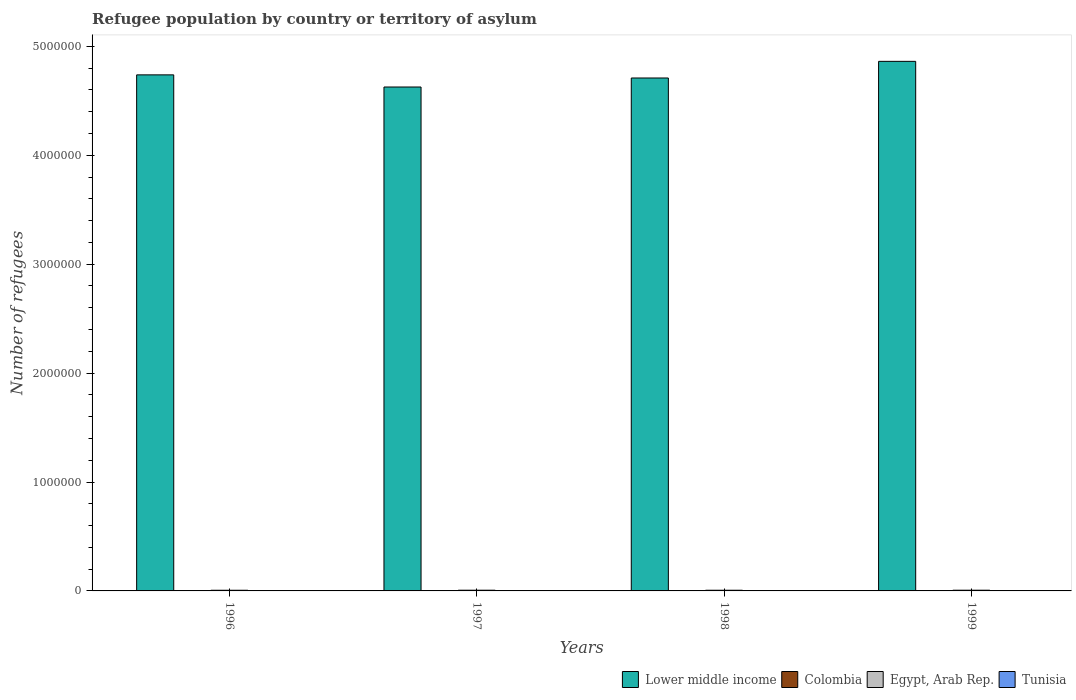How many groups of bars are there?
Your answer should be compact. 4. How many bars are there on the 4th tick from the right?
Your answer should be compact. 4. What is the label of the 1st group of bars from the left?
Give a very brief answer. 1996. In how many cases, is the number of bars for a given year not equal to the number of legend labels?
Give a very brief answer. 0. What is the number of refugees in Colombia in 1999?
Your answer should be very brief. 230. Across all years, what is the maximum number of refugees in Lower middle income?
Your answer should be compact. 4.86e+06. Across all years, what is the minimum number of refugees in Lower middle income?
Keep it short and to the point. 4.63e+06. What is the total number of refugees in Lower middle income in the graph?
Offer a very short reply. 1.89e+07. What is the difference between the number of refugees in Tunisia in 1997 and that in 1999?
Your answer should be very brief. 52. What is the difference between the number of refugees in Egypt, Arab Rep. in 1997 and the number of refugees in Lower middle income in 1996?
Ensure brevity in your answer.  -4.73e+06. What is the average number of refugees in Egypt, Arab Rep. per year?
Ensure brevity in your answer.  6339.25. In the year 1997, what is the difference between the number of refugees in Colombia and number of refugees in Tunisia?
Ensure brevity in your answer.  -283. What is the ratio of the number of refugees in Egypt, Arab Rep. in 1996 to that in 1999?
Ensure brevity in your answer.  0.92. Is the number of refugees in Tunisia in 1998 less than that in 1999?
Provide a short and direct response. No. What is the difference between the highest and the lowest number of refugees in Egypt, Arab Rep.?
Make the answer very short. 518. Is the sum of the number of refugees in Lower middle income in 1998 and 1999 greater than the maximum number of refugees in Egypt, Arab Rep. across all years?
Keep it short and to the point. Yes. What does the 1st bar from the left in 1999 represents?
Your answer should be compact. Lower middle income. What does the 1st bar from the right in 1997 represents?
Your answer should be very brief. Tunisia. Is it the case that in every year, the sum of the number of refugees in Egypt, Arab Rep. and number of refugees in Tunisia is greater than the number of refugees in Lower middle income?
Your answer should be very brief. No. How many years are there in the graph?
Make the answer very short. 4. What is the difference between two consecutive major ticks on the Y-axis?
Your answer should be compact. 1.00e+06. Does the graph contain grids?
Your answer should be very brief. No. Where does the legend appear in the graph?
Offer a terse response. Bottom right. What is the title of the graph?
Keep it short and to the point. Refugee population by country or territory of asylum. What is the label or title of the Y-axis?
Offer a terse response. Number of refugees. What is the Number of refugees of Lower middle income in 1996?
Make the answer very short. 4.74e+06. What is the Number of refugees in Colombia in 1996?
Ensure brevity in your answer.  220. What is the Number of refugees in Egypt, Arab Rep. in 1996?
Provide a succinct answer. 6035. What is the Number of refugees in Tunisia in 1996?
Provide a short and direct response. 176. What is the Number of refugees of Lower middle income in 1997?
Provide a short and direct response. 4.63e+06. What is the Number of refugees in Colombia in 1997?
Offer a very short reply. 223. What is the Number of refugees in Egypt, Arab Rep. in 1997?
Offer a terse response. 6493. What is the Number of refugees of Tunisia in 1997?
Offer a very short reply. 506. What is the Number of refugees of Lower middle income in 1998?
Keep it short and to the point. 4.71e+06. What is the Number of refugees of Colombia in 1998?
Provide a short and direct response. 226. What is the Number of refugees in Egypt, Arab Rep. in 1998?
Ensure brevity in your answer.  6276. What is the Number of refugees of Tunisia in 1998?
Ensure brevity in your answer.  528. What is the Number of refugees in Lower middle income in 1999?
Ensure brevity in your answer.  4.86e+06. What is the Number of refugees in Colombia in 1999?
Provide a short and direct response. 230. What is the Number of refugees of Egypt, Arab Rep. in 1999?
Ensure brevity in your answer.  6553. What is the Number of refugees in Tunisia in 1999?
Offer a very short reply. 454. Across all years, what is the maximum Number of refugees of Lower middle income?
Make the answer very short. 4.86e+06. Across all years, what is the maximum Number of refugees in Colombia?
Provide a succinct answer. 230. Across all years, what is the maximum Number of refugees of Egypt, Arab Rep.?
Provide a succinct answer. 6553. Across all years, what is the maximum Number of refugees in Tunisia?
Your answer should be very brief. 528. Across all years, what is the minimum Number of refugees in Lower middle income?
Keep it short and to the point. 4.63e+06. Across all years, what is the minimum Number of refugees of Colombia?
Your answer should be compact. 220. Across all years, what is the minimum Number of refugees in Egypt, Arab Rep.?
Provide a succinct answer. 6035. Across all years, what is the minimum Number of refugees in Tunisia?
Ensure brevity in your answer.  176. What is the total Number of refugees of Lower middle income in the graph?
Make the answer very short. 1.89e+07. What is the total Number of refugees of Colombia in the graph?
Your answer should be very brief. 899. What is the total Number of refugees of Egypt, Arab Rep. in the graph?
Keep it short and to the point. 2.54e+04. What is the total Number of refugees of Tunisia in the graph?
Provide a succinct answer. 1664. What is the difference between the Number of refugees in Lower middle income in 1996 and that in 1997?
Give a very brief answer. 1.11e+05. What is the difference between the Number of refugees in Egypt, Arab Rep. in 1996 and that in 1997?
Your answer should be compact. -458. What is the difference between the Number of refugees of Tunisia in 1996 and that in 1997?
Give a very brief answer. -330. What is the difference between the Number of refugees of Lower middle income in 1996 and that in 1998?
Provide a short and direct response. 2.88e+04. What is the difference between the Number of refugees in Egypt, Arab Rep. in 1996 and that in 1998?
Give a very brief answer. -241. What is the difference between the Number of refugees of Tunisia in 1996 and that in 1998?
Your response must be concise. -352. What is the difference between the Number of refugees of Lower middle income in 1996 and that in 1999?
Offer a terse response. -1.24e+05. What is the difference between the Number of refugees in Colombia in 1996 and that in 1999?
Provide a short and direct response. -10. What is the difference between the Number of refugees of Egypt, Arab Rep. in 1996 and that in 1999?
Provide a succinct answer. -518. What is the difference between the Number of refugees of Tunisia in 1996 and that in 1999?
Make the answer very short. -278. What is the difference between the Number of refugees in Lower middle income in 1997 and that in 1998?
Your answer should be very brief. -8.27e+04. What is the difference between the Number of refugees of Egypt, Arab Rep. in 1997 and that in 1998?
Provide a succinct answer. 217. What is the difference between the Number of refugees of Lower middle income in 1997 and that in 1999?
Offer a very short reply. -2.36e+05. What is the difference between the Number of refugees of Egypt, Arab Rep. in 1997 and that in 1999?
Offer a terse response. -60. What is the difference between the Number of refugees in Lower middle income in 1998 and that in 1999?
Your answer should be very brief. -1.53e+05. What is the difference between the Number of refugees of Colombia in 1998 and that in 1999?
Your response must be concise. -4. What is the difference between the Number of refugees in Egypt, Arab Rep. in 1998 and that in 1999?
Ensure brevity in your answer.  -277. What is the difference between the Number of refugees of Tunisia in 1998 and that in 1999?
Offer a very short reply. 74. What is the difference between the Number of refugees in Lower middle income in 1996 and the Number of refugees in Colombia in 1997?
Offer a terse response. 4.74e+06. What is the difference between the Number of refugees in Lower middle income in 1996 and the Number of refugees in Egypt, Arab Rep. in 1997?
Your response must be concise. 4.73e+06. What is the difference between the Number of refugees of Lower middle income in 1996 and the Number of refugees of Tunisia in 1997?
Offer a terse response. 4.74e+06. What is the difference between the Number of refugees of Colombia in 1996 and the Number of refugees of Egypt, Arab Rep. in 1997?
Make the answer very short. -6273. What is the difference between the Number of refugees in Colombia in 1996 and the Number of refugees in Tunisia in 1997?
Keep it short and to the point. -286. What is the difference between the Number of refugees of Egypt, Arab Rep. in 1996 and the Number of refugees of Tunisia in 1997?
Provide a succinct answer. 5529. What is the difference between the Number of refugees in Lower middle income in 1996 and the Number of refugees in Colombia in 1998?
Your answer should be very brief. 4.74e+06. What is the difference between the Number of refugees in Lower middle income in 1996 and the Number of refugees in Egypt, Arab Rep. in 1998?
Offer a terse response. 4.73e+06. What is the difference between the Number of refugees in Lower middle income in 1996 and the Number of refugees in Tunisia in 1998?
Offer a very short reply. 4.74e+06. What is the difference between the Number of refugees of Colombia in 1996 and the Number of refugees of Egypt, Arab Rep. in 1998?
Offer a terse response. -6056. What is the difference between the Number of refugees of Colombia in 1996 and the Number of refugees of Tunisia in 1998?
Your answer should be compact. -308. What is the difference between the Number of refugees in Egypt, Arab Rep. in 1996 and the Number of refugees in Tunisia in 1998?
Your answer should be very brief. 5507. What is the difference between the Number of refugees of Lower middle income in 1996 and the Number of refugees of Colombia in 1999?
Provide a succinct answer. 4.74e+06. What is the difference between the Number of refugees of Lower middle income in 1996 and the Number of refugees of Egypt, Arab Rep. in 1999?
Your answer should be compact. 4.73e+06. What is the difference between the Number of refugees of Lower middle income in 1996 and the Number of refugees of Tunisia in 1999?
Offer a terse response. 4.74e+06. What is the difference between the Number of refugees of Colombia in 1996 and the Number of refugees of Egypt, Arab Rep. in 1999?
Offer a terse response. -6333. What is the difference between the Number of refugees in Colombia in 1996 and the Number of refugees in Tunisia in 1999?
Your response must be concise. -234. What is the difference between the Number of refugees of Egypt, Arab Rep. in 1996 and the Number of refugees of Tunisia in 1999?
Keep it short and to the point. 5581. What is the difference between the Number of refugees in Lower middle income in 1997 and the Number of refugees in Colombia in 1998?
Offer a terse response. 4.63e+06. What is the difference between the Number of refugees in Lower middle income in 1997 and the Number of refugees in Egypt, Arab Rep. in 1998?
Your response must be concise. 4.62e+06. What is the difference between the Number of refugees in Lower middle income in 1997 and the Number of refugees in Tunisia in 1998?
Give a very brief answer. 4.63e+06. What is the difference between the Number of refugees of Colombia in 1997 and the Number of refugees of Egypt, Arab Rep. in 1998?
Provide a short and direct response. -6053. What is the difference between the Number of refugees in Colombia in 1997 and the Number of refugees in Tunisia in 1998?
Offer a very short reply. -305. What is the difference between the Number of refugees in Egypt, Arab Rep. in 1997 and the Number of refugees in Tunisia in 1998?
Provide a succinct answer. 5965. What is the difference between the Number of refugees of Lower middle income in 1997 and the Number of refugees of Colombia in 1999?
Provide a succinct answer. 4.63e+06. What is the difference between the Number of refugees in Lower middle income in 1997 and the Number of refugees in Egypt, Arab Rep. in 1999?
Your answer should be very brief. 4.62e+06. What is the difference between the Number of refugees in Lower middle income in 1997 and the Number of refugees in Tunisia in 1999?
Your answer should be compact. 4.63e+06. What is the difference between the Number of refugees of Colombia in 1997 and the Number of refugees of Egypt, Arab Rep. in 1999?
Provide a short and direct response. -6330. What is the difference between the Number of refugees of Colombia in 1997 and the Number of refugees of Tunisia in 1999?
Offer a very short reply. -231. What is the difference between the Number of refugees of Egypt, Arab Rep. in 1997 and the Number of refugees of Tunisia in 1999?
Give a very brief answer. 6039. What is the difference between the Number of refugees of Lower middle income in 1998 and the Number of refugees of Colombia in 1999?
Give a very brief answer. 4.71e+06. What is the difference between the Number of refugees of Lower middle income in 1998 and the Number of refugees of Egypt, Arab Rep. in 1999?
Ensure brevity in your answer.  4.70e+06. What is the difference between the Number of refugees of Lower middle income in 1998 and the Number of refugees of Tunisia in 1999?
Keep it short and to the point. 4.71e+06. What is the difference between the Number of refugees in Colombia in 1998 and the Number of refugees in Egypt, Arab Rep. in 1999?
Ensure brevity in your answer.  -6327. What is the difference between the Number of refugees of Colombia in 1998 and the Number of refugees of Tunisia in 1999?
Your response must be concise. -228. What is the difference between the Number of refugees in Egypt, Arab Rep. in 1998 and the Number of refugees in Tunisia in 1999?
Provide a succinct answer. 5822. What is the average Number of refugees of Lower middle income per year?
Provide a succinct answer. 4.73e+06. What is the average Number of refugees of Colombia per year?
Give a very brief answer. 224.75. What is the average Number of refugees of Egypt, Arab Rep. per year?
Your answer should be very brief. 6339.25. What is the average Number of refugees of Tunisia per year?
Your response must be concise. 416. In the year 1996, what is the difference between the Number of refugees of Lower middle income and Number of refugees of Colombia?
Make the answer very short. 4.74e+06. In the year 1996, what is the difference between the Number of refugees of Lower middle income and Number of refugees of Egypt, Arab Rep.?
Your response must be concise. 4.73e+06. In the year 1996, what is the difference between the Number of refugees of Lower middle income and Number of refugees of Tunisia?
Your answer should be compact. 4.74e+06. In the year 1996, what is the difference between the Number of refugees of Colombia and Number of refugees of Egypt, Arab Rep.?
Provide a succinct answer. -5815. In the year 1996, what is the difference between the Number of refugees in Egypt, Arab Rep. and Number of refugees in Tunisia?
Keep it short and to the point. 5859. In the year 1997, what is the difference between the Number of refugees of Lower middle income and Number of refugees of Colombia?
Offer a very short reply. 4.63e+06. In the year 1997, what is the difference between the Number of refugees of Lower middle income and Number of refugees of Egypt, Arab Rep.?
Offer a terse response. 4.62e+06. In the year 1997, what is the difference between the Number of refugees of Lower middle income and Number of refugees of Tunisia?
Give a very brief answer. 4.63e+06. In the year 1997, what is the difference between the Number of refugees of Colombia and Number of refugees of Egypt, Arab Rep.?
Ensure brevity in your answer.  -6270. In the year 1997, what is the difference between the Number of refugees of Colombia and Number of refugees of Tunisia?
Offer a very short reply. -283. In the year 1997, what is the difference between the Number of refugees of Egypt, Arab Rep. and Number of refugees of Tunisia?
Your response must be concise. 5987. In the year 1998, what is the difference between the Number of refugees in Lower middle income and Number of refugees in Colombia?
Give a very brief answer. 4.71e+06. In the year 1998, what is the difference between the Number of refugees in Lower middle income and Number of refugees in Egypt, Arab Rep.?
Your answer should be compact. 4.70e+06. In the year 1998, what is the difference between the Number of refugees of Lower middle income and Number of refugees of Tunisia?
Provide a short and direct response. 4.71e+06. In the year 1998, what is the difference between the Number of refugees of Colombia and Number of refugees of Egypt, Arab Rep.?
Offer a very short reply. -6050. In the year 1998, what is the difference between the Number of refugees in Colombia and Number of refugees in Tunisia?
Make the answer very short. -302. In the year 1998, what is the difference between the Number of refugees of Egypt, Arab Rep. and Number of refugees of Tunisia?
Give a very brief answer. 5748. In the year 1999, what is the difference between the Number of refugees in Lower middle income and Number of refugees in Colombia?
Your response must be concise. 4.86e+06. In the year 1999, what is the difference between the Number of refugees of Lower middle income and Number of refugees of Egypt, Arab Rep.?
Provide a succinct answer. 4.86e+06. In the year 1999, what is the difference between the Number of refugees in Lower middle income and Number of refugees in Tunisia?
Your response must be concise. 4.86e+06. In the year 1999, what is the difference between the Number of refugees in Colombia and Number of refugees in Egypt, Arab Rep.?
Offer a very short reply. -6323. In the year 1999, what is the difference between the Number of refugees of Colombia and Number of refugees of Tunisia?
Your answer should be very brief. -224. In the year 1999, what is the difference between the Number of refugees in Egypt, Arab Rep. and Number of refugees in Tunisia?
Your response must be concise. 6099. What is the ratio of the Number of refugees in Lower middle income in 1996 to that in 1997?
Provide a succinct answer. 1.02. What is the ratio of the Number of refugees of Colombia in 1996 to that in 1997?
Provide a succinct answer. 0.99. What is the ratio of the Number of refugees in Egypt, Arab Rep. in 1996 to that in 1997?
Provide a short and direct response. 0.93. What is the ratio of the Number of refugees in Tunisia in 1996 to that in 1997?
Your answer should be very brief. 0.35. What is the ratio of the Number of refugees of Lower middle income in 1996 to that in 1998?
Provide a succinct answer. 1.01. What is the ratio of the Number of refugees of Colombia in 1996 to that in 1998?
Give a very brief answer. 0.97. What is the ratio of the Number of refugees of Egypt, Arab Rep. in 1996 to that in 1998?
Ensure brevity in your answer.  0.96. What is the ratio of the Number of refugees of Tunisia in 1996 to that in 1998?
Your answer should be compact. 0.33. What is the ratio of the Number of refugees of Lower middle income in 1996 to that in 1999?
Offer a very short reply. 0.97. What is the ratio of the Number of refugees of Colombia in 1996 to that in 1999?
Offer a very short reply. 0.96. What is the ratio of the Number of refugees in Egypt, Arab Rep. in 1996 to that in 1999?
Provide a succinct answer. 0.92. What is the ratio of the Number of refugees in Tunisia in 1996 to that in 1999?
Ensure brevity in your answer.  0.39. What is the ratio of the Number of refugees of Lower middle income in 1997 to that in 1998?
Ensure brevity in your answer.  0.98. What is the ratio of the Number of refugees in Colombia in 1997 to that in 1998?
Your answer should be very brief. 0.99. What is the ratio of the Number of refugees in Egypt, Arab Rep. in 1997 to that in 1998?
Your answer should be very brief. 1.03. What is the ratio of the Number of refugees of Lower middle income in 1997 to that in 1999?
Give a very brief answer. 0.95. What is the ratio of the Number of refugees in Colombia in 1997 to that in 1999?
Your response must be concise. 0.97. What is the ratio of the Number of refugees of Tunisia in 1997 to that in 1999?
Make the answer very short. 1.11. What is the ratio of the Number of refugees in Lower middle income in 1998 to that in 1999?
Keep it short and to the point. 0.97. What is the ratio of the Number of refugees of Colombia in 1998 to that in 1999?
Ensure brevity in your answer.  0.98. What is the ratio of the Number of refugees in Egypt, Arab Rep. in 1998 to that in 1999?
Ensure brevity in your answer.  0.96. What is the ratio of the Number of refugees of Tunisia in 1998 to that in 1999?
Your answer should be compact. 1.16. What is the difference between the highest and the second highest Number of refugees of Lower middle income?
Your answer should be very brief. 1.24e+05. What is the difference between the highest and the second highest Number of refugees of Colombia?
Offer a very short reply. 4. What is the difference between the highest and the second highest Number of refugees of Egypt, Arab Rep.?
Give a very brief answer. 60. What is the difference between the highest and the lowest Number of refugees in Lower middle income?
Offer a very short reply. 2.36e+05. What is the difference between the highest and the lowest Number of refugees of Egypt, Arab Rep.?
Give a very brief answer. 518. What is the difference between the highest and the lowest Number of refugees in Tunisia?
Give a very brief answer. 352. 